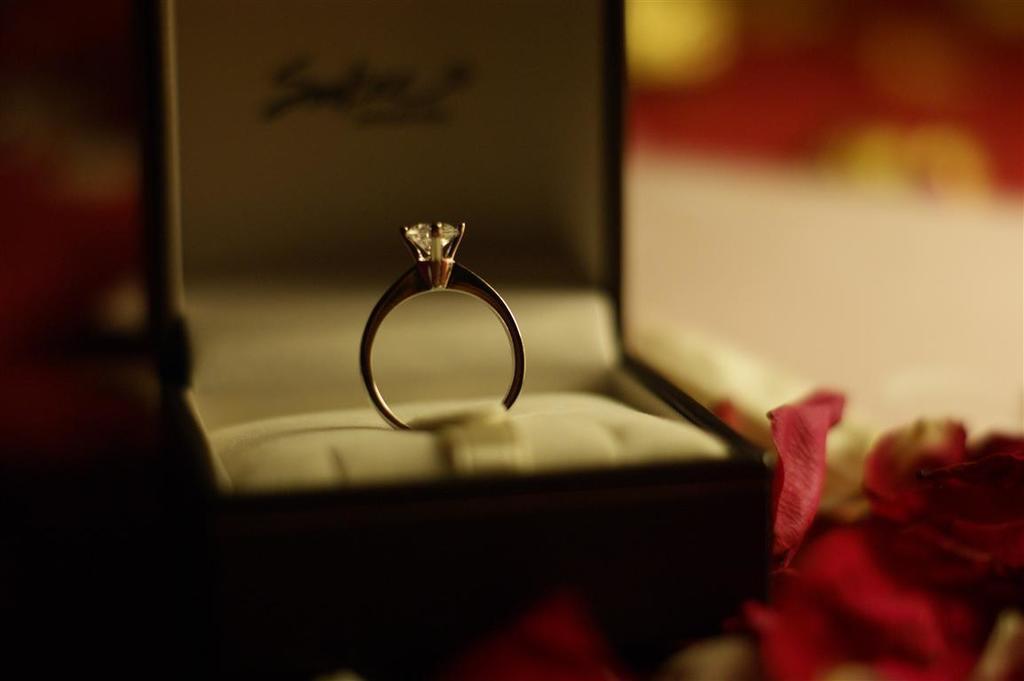Could you give a brief overview of what you see in this image? In this picture we can see a ring in the box. There are few roses petals. Background is blurry. 